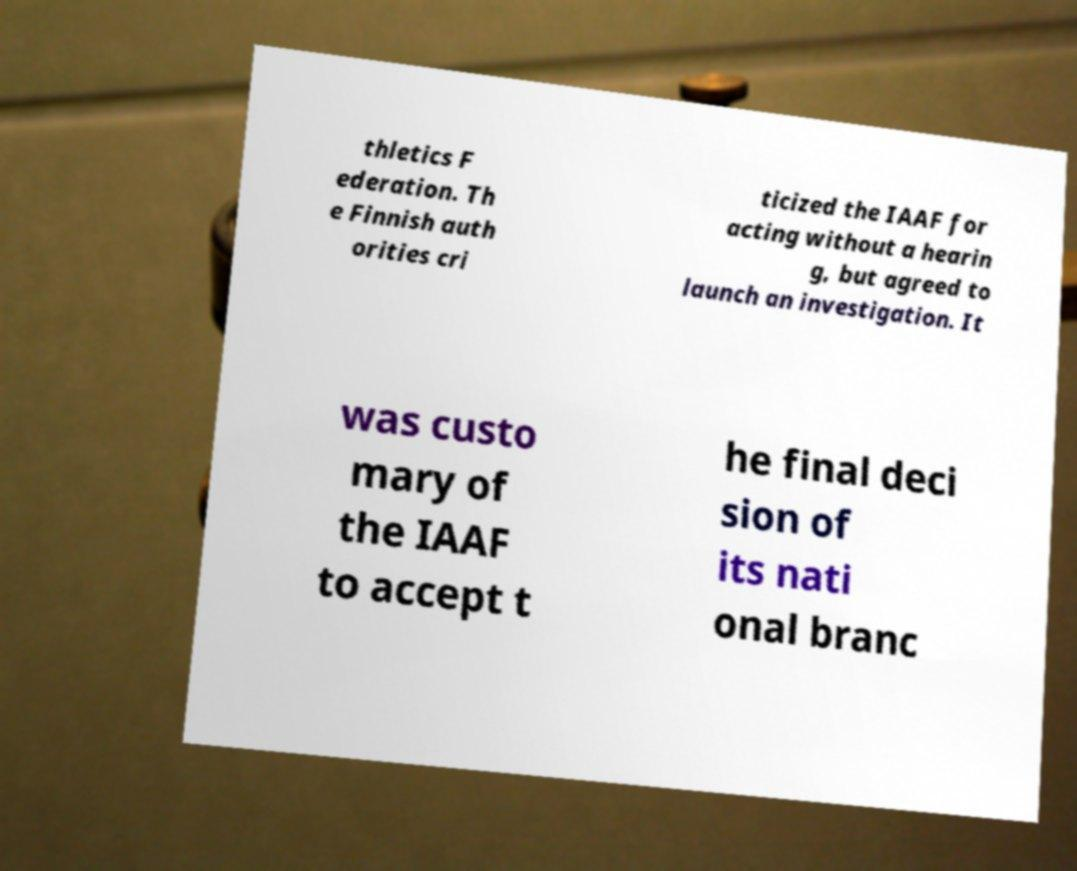Can you read and provide the text displayed in the image?This photo seems to have some interesting text. Can you extract and type it out for me? thletics F ederation. Th e Finnish auth orities cri ticized the IAAF for acting without a hearin g, but agreed to launch an investigation. It was custo mary of the IAAF to accept t he final deci sion of its nati onal branc 